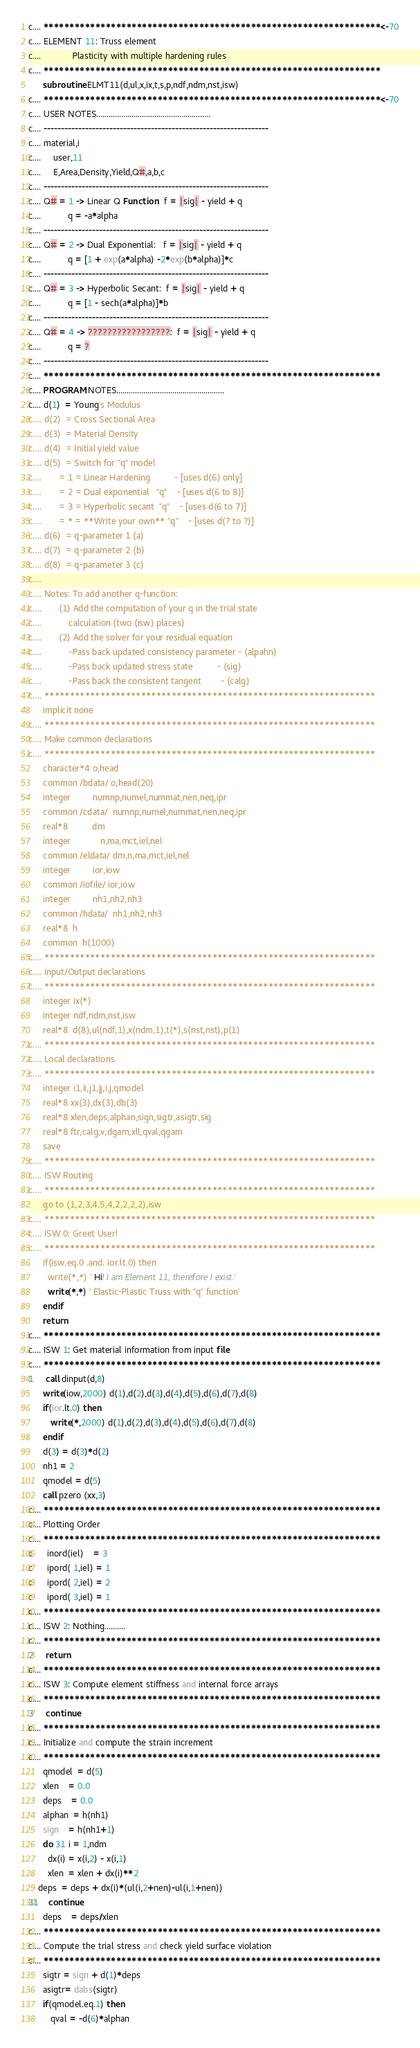<code> <loc_0><loc_0><loc_500><loc_500><_FORTRAN_>c.... *****************************************************************<-70
c.... ELEMENT 11: Truss element 
c....             Plasticity with multiple hardening rules
c.... *****************************************************************
      subroutine ELMT11(d,ul,x,ix,t,s,p,ndf,ndm,nst,isw)
c.... *****************************************************************<-70
c.... USER NOTES.......................................................
c.... -----------------------------------------------------------------
c.... material,i
c....     user,11
c....     E,Area,Density,Yield,Q#,a,b,c
c.... -----------------------------------------------------------------
c.... Q# = 1 -> Linear Q Function:  f = |sig| - yield + q
c....           q = -a*alpha
c.... -----------------------------------------------------------------
c.... Q# = 2 -> Dual Exponential:   f = |sig| - yield + q
c....           q = [1 + exp(a*alpha) -2*exp(b*alpha)]*c
c.... -----------------------------------------------------------------
c.... Q# = 3 -> Hyperbolic Secant:  f = |sig| - yield + q
c....           q = [1 - sech(a*alpha)]*b
c.... -----------------------------------------------------------------
c.... Q# = 4 -> ?????????????????:  f = |sig| - yield + q
c....           q = ?
c.... -----------------------------------------------------------------
c.... *****************************************************************
c.... PROGRAM NOTES.................................................... 
c.... d(1)  = Young's Modulus
c.... d(2)  = Cross Sectional Area
c.... d(3)  = Material Density
c.... d(4)  = Initial yield value
c.... d(5)  = Switch for "q" model
c....       = 1 = Linear Hardening          - [uses d(6) only]
c....       = 2 = Dual exponential   "q"    - [uses d(6 to 8)]
c....       = 3 = Hyperbolic secant  "q"    - [uses d(6 to 7)]
c....       = * = **Write your own** "q"    - [uses d(? to ?)]
c.... d(6)  = q-parameter 1 (a)
c.... d(7)  = q-parameter 2 (b)
c.... d(8)  = q-parameter 3 (c)
c....
c.... Notes: To add another q-function:
c....       (1) Add the computation of your q in the trial state 
c....           calculation (two (isw) places)
c....       (2) Add the solver for your residual equation
c....           -Pass back updated consistency parameter - (alpahn)
c....           -Pass back updated stress state          - (sig)
c....           -Pass back the consistent tangent        - (calg)
c.... *****************************************************************
      implicit none
c.... *****************************************************************
c.... Make common declarations
c.... *****************************************************************
      character*4 o,head
      common /bdata/ o,head(20)
      integer         numnp,numel,nummat,nen,neq,ipr
      common /cdata/  numnp,numel,nummat,nen,neq,ipr
      real*8          dm
      integer            n,ma,mct,iel,nel
      common /eldata/ dm,n,ma,mct,iel,nel
      integer         ior,iow
      common /iofile/ ior,iow
      integer         nh1,nh2,nh3
      common /hdata/  nh1,nh2,nh3
      real*8  h
      common  h(1000)
c.... *****************************************************************
c.... Input/Output declarations
c.... *****************************************************************
      integer ix(*)
      integer ndf,ndm,nst,isw
      real*8  d(8),ul(ndf,1),x(ndm,1),t(*),s(nst,nst),p(1)   
c.... *****************************************************************
c.... Local declarations
c.... *****************************************************************
      integer i1,ii,j1,jj,i,j,qmodel
      real*8 xx(3),dx(3),db(3)
      real*8 xlen,deps,alphan,sign,sigtr,asigtr,sig
      real*8 ftr,calg,v,dgam,xll,qval,qgam
      save 
c.... *****************************************************************
c.... ISW Routing
c.... *****************************************************************
      go to (1,2,3,4,5,4,2,2,2,2),isw
c.... *****************************************************************
c.... ISW 0: Greet User!
c.... *****************************************************************
      if(isw.eq.0 .and. ior.lt.0) then
        write(*,*) ' Hi! I am Element 11, therefore I exist.'
        write(*,*) ' Elastic-Plastic Truss with "q" function'
      endif
      return
c.... *****************************************************************
c.... ISW 1: Get material information from input file
c.... *****************************************************************
1     call dinput(d,8)
      write(iow,2000) d(1),d(2),d(3),d(4),d(5),d(6),d(7),d(8)
      if(ior.lt.0) then
         write(*,2000) d(1),d(2),d(3),d(4),d(5),d(6),d(7),d(8)
      endif
      d(3) = d(3)*d(2)
      nh1 = 2         
      qmodel = d(5)
      call pzero (xx,3)
c.... *****************************************************************
c.... Plotting Order
c.... *****************************************************************
c      inord(iel)    = 3
c      ipord( 1,iel) = 1
c      ipord( 2,iel) = 2
c      ipord( 3,iel) = 1
c.... *****************************************************************
c.... ISW 2: Nothing..........
c.... *****************************************************************
2     return
c.... *****************************************************************
c.... ISW 3: Compute element stiffness and internal force arrays
c.... *****************************************************************
3     continue
c.... *****************************************************************
c.... Initialize and compute the strain increment
c.... *****************************************************************
      qmodel  = d(5)
      xlen    = 0.0
      deps    = 0.0
      alphan  = h(nh1)
      sign    = h(nh1+1)
      do 31 i = 1,ndm
        dx(i) = x(i,2) - x(i,1)
        xlen  = xlen + dx(i)**2
	deps  = deps + dx(i)*(ul(i,2+nen)-ul(i,1+nen))
31    continue
      deps    = deps/xlen
c.... *****************************************************************
c.... Compute the trial stress and check yield surface violation
c.... *****************************************************************
      sigtr = sign + d(1)*deps
      asigtr= dabs(sigtr)
      if(qmodel.eq.1) then
         qval = -d(6)*alphan</code> 